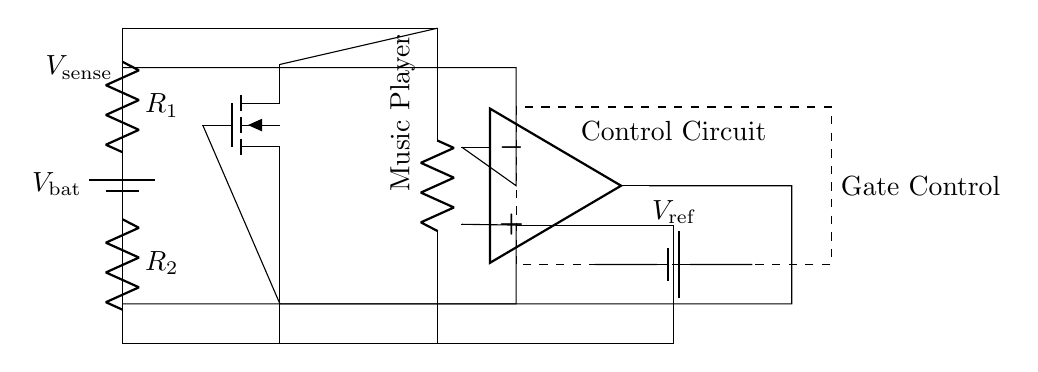What type of load is connected in this circuit? The load is labeled as "Music Player," indicating that it is designed for audio playback in portable devices.
Answer: Music Player What is the role of the MOSFET in this circuit? The MOSFET acts as a switch to control the charging of the battery and protect against overcharging by regulating current flow based on the control signal.
Answer: Switch What is the purpose of the voltage divider in this circuit? The voltage divider, consisting of resistors R1 and R2, is used to reduce the voltage to a level that can be compared by the operational amplifier to determine if the battery is being overcharged.
Answer: Reduce voltage What component provides the reference voltage? The reference voltage is provided by a battery labeled as "V_ref." It sets the threshold for the comparator to decide when to cut off charging.
Answer: V_ref What triggers the gate control of the MOSFET? The gate control of the MOSFET is triggered by the output of the operational amplifier, which receives inputs from the voltage divider to compare the sensed voltage against the reference voltage.
Answer: Operational amplifier How can you tell if the battery is being overcharged? The battery is considered to be overcharged when the sensed voltage (V_sense) exceeds the reference voltage (V_ref), which the comparator evaluates based on the output voltage from the voltage divider.
Answer: Exceeding V_ref What type of circuit is this setup an example of? This setup is an example of a protection circuit designed specifically for preventing battery overcharge in portable devices, ensuring safe operation and longevity of the battery.
Answer: Protection circuit 